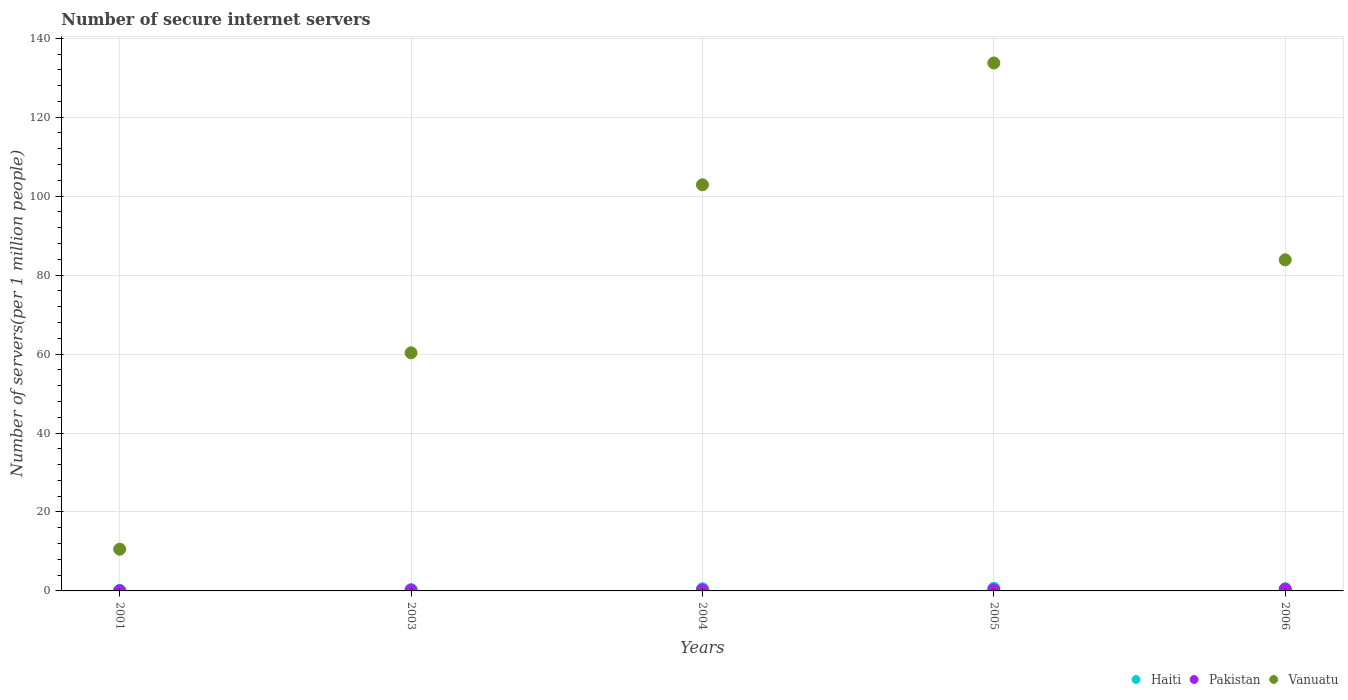Is the number of dotlines equal to the number of legend labels?
Make the answer very short. Yes. What is the number of secure internet servers in Haiti in 2005?
Your answer should be compact. 0.65. Across all years, what is the maximum number of secure internet servers in Vanuatu?
Your answer should be compact. 133.73. Across all years, what is the minimum number of secure internet servers in Vanuatu?
Ensure brevity in your answer.  10.57. In which year was the number of secure internet servers in Haiti maximum?
Provide a short and direct response. 2005. What is the total number of secure internet servers in Pakistan in the graph?
Your answer should be compact. 1.2. What is the difference between the number of secure internet servers in Vanuatu in 2001 and that in 2003?
Offer a very short reply. -49.75. What is the difference between the number of secure internet servers in Haiti in 2004 and the number of secure internet servers in Pakistan in 2001?
Offer a terse response. 0.51. What is the average number of secure internet servers in Vanuatu per year?
Your response must be concise. 78.27. In the year 2001, what is the difference between the number of secure internet servers in Pakistan and number of secure internet servers in Haiti?
Make the answer very short. -0.07. In how many years, is the number of secure internet servers in Pakistan greater than 136?
Provide a short and direct response. 0. What is the ratio of the number of secure internet servers in Haiti in 2004 to that in 2005?
Keep it short and to the point. 0.85. Is the number of secure internet servers in Haiti in 2001 less than that in 2004?
Your answer should be compact. Yes. What is the difference between the highest and the second highest number of secure internet servers in Pakistan?
Your response must be concise. 0.14. What is the difference between the highest and the lowest number of secure internet servers in Pakistan?
Give a very brief answer. 0.4. In how many years, is the number of secure internet servers in Haiti greater than the average number of secure internet servers in Haiti taken over all years?
Make the answer very short. 3. Is the number of secure internet servers in Pakistan strictly greater than the number of secure internet servers in Vanuatu over the years?
Your response must be concise. No. How many years are there in the graph?
Provide a short and direct response. 5. What is the difference between two consecutive major ticks on the Y-axis?
Give a very brief answer. 20. Are the values on the major ticks of Y-axis written in scientific E-notation?
Keep it short and to the point. No. Where does the legend appear in the graph?
Your answer should be very brief. Bottom right. How many legend labels are there?
Your response must be concise. 3. How are the legend labels stacked?
Keep it short and to the point. Horizontal. What is the title of the graph?
Make the answer very short. Number of secure internet servers. Does "Brazil" appear as one of the legend labels in the graph?
Make the answer very short. No. What is the label or title of the X-axis?
Your answer should be very brief. Years. What is the label or title of the Y-axis?
Give a very brief answer. Number of servers(per 1 million people). What is the Number of servers(per 1 million people) of Haiti in 2001?
Give a very brief answer. 0.12. What is the Number of servers(per 1 million people) of Pakistan in 2001?
Your answer should be very brief. 0.04. What is the Number of servers(per 1 million people) of Vanuatu in 2001?
Provide a short and direct response. 10.57. What is the Number of servers(per 1 million people) in Haiti in 2003?
Offer a very short reply. 0.33. What is the Number of servers(per 1 million people) of Pakistan in 2003?
Give a very brief answer. 0.17. What is the Number of servers(per 1 million people) in Vanuatu in 2003?
Provide a short and direct response. 60.31. What is the Number of servers(per 1 million people) in Haiti in 2004?
Give a very brief answer. 0.55. What is the Number of servers(per 1 million people) of Pakistan in 2004?
Provide a succinct answer. 0.25. What is the Number of servers(per 1 million people) of Vanuatu in 2004?
Your answer should be compact. 102.87. What is the Number of servers(per 1 million people) of Haiti in 2005?
Make the answer very short. 0.65. What is the Number of servers(per 1 million people) in Pakistan in 2005?
Offer a very short reply. 0.3. What is the Number of servers(per 1 million people) of Vanuatu in 2005?
Make the answer very short. 133.73. What is the Number of servers(per 1 million people) of Haiti in 2006?
Offer a very short reply. 0.53. What is the Number of servers(per 1 million people) in Pakistan in 2006?
Keep it short and to the point. 0.44. What is the Number of servers(per 1 million people) of Vanuatu in 2006?
Your answer should be compact. 83.86. Across all years, what is the maximum Number of servers(per 1 million people) in Haiti?
Your answer should be very brief. 0.65. Across all years, what is the maximum Number of servers(per 1 million people) of Pakistan?
Your answer should be very brief. 0.44. Across all years, what is the maximum Number of servers(per 1 million people) in Vanuatu?
Your response must be concise. 133.73. Across all years, what is the minimum Number of servers(per 1 million people) of Haiti?
Your answer should be very brief. 0.12. Across all years, what is the minimum Number of servers(per 1 million people) in Pakistan?
Offer a terse response. 0.04. Across all years, what is the minimum Number of servers(per 1 million people) of Vanuatu?
Keep it short and to the point. 10.57. What is the total Number of servers(per 1 million people) in Haiti in the graph?
Offer a very short reply. 2.18. What is the total Number of servers(per 1 million people) of Pakistan in the graph?
Your response must be concise. 1.2. What is the total Number of servers(per 1 million people) in Vanuatu in the graph?
Your response must be concise. 391.34. What is the difference between the Number of servers(per 1 million people) of Haiti in 2001 and that in 2003?
Keep it short and to the point. -0.22. What is the difference between the Number of servers(per 1 million people) of Pakistan in 2001 and that in 2003?
Your answer should be very brief. -0.13. What is the difference between the Number of servers(per 1 million people) of Vanuatu in 2001 and that in 2003?
Provide a succinct answer. -49.75. What is the difference between the Number of servers(per 1 million people) of Haiti in 2001 and that in 2004?
Keep it short and to the point. -0.43. What is the difference between the Number of servers(per 1 million people) of Pakistan in 2001 and that in 2004?
Ensure brevity in your answer.  -0.2. What is the difference between the Number of servers(per 1 million people) of Vanuatu in 2001 and that in 2004?
Make the answer very short. -92.3. What is the difference between the Number of servers(per 1 million people) in Haiti in 2001 and that in 2005?
Offer a terse response. -0.53. What is the difference between the Number of servers(per 1 million people) of Pakistan in 2001 and that in 2005?
Provide a succinct answer. -0.26. What is the difference between the Number of servers(per 1 million people) in Vanuatu in 2001 and that in 2005?
Offer a very short reply. -123.17. What is the difference between the Number of servers(per 1 million people) of Haiti in 2001 and that in 2006?
Keep it short and to the point. -0.42. What is the difference between the Number of servers(per 1 million people) of Pakistan in 2001 and that in 2006?
Provide a succinct answer. -0.4. What is the difference between the Number of servers(per 1 million people) in Vanuatu in 2001 and that in 2006?
Provide a short and direct response. -73.3. What is the difference between the Number of servers(per 1 million people) of Haiti in 2003 and that in 2004?
Offer a very short reply. -0.21. What is the difference between the Number of servers(per 1 million people) of Pakistan in 2003 and that in 2004?
Provide a short and direct response. -0.08. What is the difference between the Number of servers(per 1 million people) in Vanuatu in 2003 and that in 2004?
Give a very brief answer. -42.56. What is the difference between the Number of servers(per 1 million people) of Haiti in 2003 and that in 2005?
Provide a short and direct response. -0.31. What is the difference between the Number of servers(per 1 million people) of Pakistan in 2003 and that in 2005?
Provide a succinct answer. -0.13. What is the difference between the Number of servers(per 1 million people) of Vanuatu in 2003 and that in 2005?
Offer a terse response. -73.42. What is the difference between the Number of servers(per 1 million people) in Haiti in 2003 and that in 2006?
Give a very brief answer. -0.2. What is the difference between the Number of servers(per 1 million people) of Pakistan in 2003 and that in 2006?
Make the answer very short. -0.27. What is the difference between the Number of servers(per 1 million people) of Vanuatu in 2003 and that in 2006?
Offer a terse response. -23.55. What is the difference between the Number of servers(per 1 million people) in Haiti in 2004 and that in 2005?
Make the answer very short. -0.1. What is the difference between the Number of servers(per 1 million people) of Pakistan in 2004 and that in 2005?
Make the answer very short. -0.05. What is the difference between the Number of servers(per 1 million people) of Vanuatu in 2004 and that in 2005?
Give a very brief answer. -30.86. What is the difference between the Number of servers(per 1 million people) of Haiti in 2004 and that in 2006?
Ensure brevity in your answer.  0.02. What is the difference between the Number of servers(per 1 million people) of Pakistan in 2004 and that in 2006?
Keep it short and to the point. -0.19. What is the difference between the Number of servers(per 1 million people) of Vanuatu in 2004 and that in 2006?
Your answer should be compact. 19.01. What is the difference between the Number of servers(per 1 million people) of Haiti in 2005 and that in 2006?
Make the answer very short. 0.12. What is the difference between the Number of servers(per 1 million people) in Pakistan in 2005 and that in 2006?
Your answer should be compact. -0.14. What is the difference between the Number of servers(per 1 million people) of Vanuatu in 2005 and that in 2006?
Ensure brevity in your answer.  49.87. What is the difference between the Number of servers(per 1 million people) in Haiti in 2001 and the Number of servers(per 1 million people) in Pakistan in 2003?
Your answer should be very brief. -0.05. What is the difference between the Number of servers(per 1 million people) in Haiti in 2001 and the Number of servers(per 1 million people) in Vanuatu in 2003?
Your answer should be compact. -60.2. What is the difference between the Number of servers(per 1 million people) of Pakistan in 2001 and the Number of servers(per 1 million people) of Vanuatu in 2003?
Provide a short and direct response. -60.27. What is the difference between the Number of servers(per 1 million people) of Haiti in 2001 and the Number of servers(per 1 million people) of Pakistan in 2004?
Your answer should be compact. -0.13. What is the difference between the Number of servers(per 1 million people) in Haiti in 2001 and the Number of servers(per 1 million people) in Vanuatu in 2004?
Give a very brief answer. -102.75. What is the difference between the Number of servers(per 1 million people) of Pakistan in 2001 and the Number of servers(per 1 million people) of Vanuatu in 2004?
Keep it short and to the point. -102.83. What is the difference between the Number of servers(per 1 million people) in Haiti in 2001 and the Number of servers(per 1 million people) in Pakistan in 2005?
Your answer should be very brief. -0.18. What is the difference between the Number of servers(per 1 million people) of Haiti in 2001 and the Number of servers(per 1 million people) of Vanuatu in 2005?
Offer a terse response. -133.62. What is the difference between the Number of servers(per 1 million people) in Pakistan in 2001 and the Number of servers(per 1 million people) in Vanuatu in 2005?
Give a very brief answer. -133.69. What is the difference between the Number of servers(per 1 million people) in Haiti in 2001 and the Number of servers(per 1 million people) in Pakistan in 2006?
Offer a terse response. -0.33. What is the difference between the Number of servers(per 1 million people) of Haiti in 2001 and the Number of servers(per 1 million people) of Vanuatu in 2006?
Give a very brief answer. -83.75. What is the difference between the Number of servers(per 1 million people) of Pakistan in 2001 and the Number of servers(per 1 million people) of Vanuatu in 2006?
Provide a succinct answer. -83.82. What is the difference between the Number of servers(per 1 million people) of Haiti in 2003 and the Number of servers(per 1 million people) of Pakistan in 2004?
Make the answer very short. 0.09. What is the difference between the Number of servers(per 1 million people) of Haiti in 2003 and the Number of servers(per 1 million people) of Vanuatu in 2004?
Keep it short and to the point. -102.53. What is the difference between the Number of servers(per 1 million people) in Pakistan in 2003 and the Number of servers(per 1 million people) in Vanuatu in 2004?
Ensure brevity in your answer.  -102.7. What is the difference between the Number of servers(per 1 million people) of Haiti in 2003 and the Number of servers(per 1 million people) of Pakistan in 2005?
Your answer should be very brief. 0.03. What is the difference between the Number of servers(per 1 million people) of Haiti in 2003 and the Number of servers(per 1 million people) of Vanuatu in 2005?
Give a very brief answer. -133.4. What is the difference between the Number of servers(per 1 million people) in Pakistan in 2003 and the Number of servers(per 1 million people) in Vanuatu in 2005?
Make the answer very short. -133.56. What is the difference between the Number of servers(per 1 million people) of Haiti in 2003 and the Number of servers(per 1 million people) of Pakistan in 2006?
Your answer should be very brief. -0.11. What is the difference between the Number of servers(per 1 million people) of Haiti in 2003 and the Number of servers(per 1 million people) of Vanuatu in 2006?
Your response must be concise. -83.53. What is the difference between the Number of servers(per 1 million people) of Pakistan in 2003 and the Number of servers(per 1 million people) of Vanuatu in 2006?
Ensure brevity in your answer.  -83.69. What is the difference between the Number of servers(per 1 million people) in Haiti in 2004 and the Number of servers(per 1 million people) in Pakistan in 2005?
Give a very brief answer. 0.25. What is the difference between the Number of servers(per 1 million people) in Haiti in 2004 and the Number of servers(per 1 million people) in Vanuatu in 2005?
Your answer should be compact. -133.18. What is the difference between the Number of servers(per 1 million people) in Pakistan in 2004 and the Number of servers(per 1 million people) in Vanuatu in 2005?
Offer a very short reply. -133.49. What is the difference between the Number of servers(per 1 million people) in Haiti in 2004 and the Number of servers(per 1 million people) in Pakistan in 2006?
Your response must be concise. 0.11. What is the difference between the Number of servers(per 1 million people) in Haiti in 2004 and the Number of servers(per 1 million people) in Vanuatu in 2006?
Make the answer very short. -83.31. What is the difference between the Number of servers(per 1 million people) of Pakistan in 2004 and the Number of servers(per 1 million people) of Vanuatu in 2006?
Provide a succinct answer. -83.62. What is the difference between the Number of servers(per 1 million people) of Haiti in 2005 and the Number of servers(per 1 million people) of Pakistan in 2006?
Provide a short and direct response. 0.21. What is the difference between the Number of servers(per 1 million people) of Haiti in 2005 and the Number of servers(per 1 million people) of Vanuatu in 2006?
Your response must be concise. -83.22. What is the difference between the Number of servers(per 1 million people) of Pakistan in 2005 and the Number of servers(per 1 million people) of Vanuatu in 2006?
Your answer should be compact. -83.56. What is the average Number of servers(per 1 million people) in Haiti per year?
Offer a terse response. 0.44. What is the average Number of servers(per 1 million people) of Pakistan per year?
Make the answer very short. 0.24. What is the average Number of servers(per 1 million people) of Vanuatu per year?
Your answer should be very brief. 78.27. In the year 2001, what is the difference between the Number of servers(per 1 million people) in Haiti and Number of servers(per 1 million people) in Pakistan?
Offer a terse response. 0.07. In the year 2001, what is the difference between the Number of servers(per 1 million people) in Haiti and Number of servers(per 1 million people) in Vanuatu?
Offer a terse response. -10.45. In the year 2001, what is the difference between the Number of servers(per 1 million people) of Pakistan and Number of servers(per 1 million people) of Vanuatu?
Offer a terse response. -10.52. In the year 2003, what is the difference between the Number of servers(per 1 million people) in Haiti and Number of servers(per 1 million people) in Pakistan?
Ensure brevity in your answer.  0.16. In the year 2003, what is the difference between the Number of servers(per 1 million people) of Haiti and Number of servers(per 1 million people) of Vanuatu?
Give a very brief answer. -59.98. In the year 2003, what is the difference between the Number of servers(per 1 million people) in Pakistan and Number of servers(per 1 million people) in Vanuatu?
Offer a terse response. -60.14. In the year 2004, what is the difference between the Number of servers(per 1 million people) of Haiti and Number of servers(per 1 million people) of Pakistan?
Ensure brevity in your answer.  0.3. In the year 2004, what is the difference between the Number of servers(per 1 million people) in Haiti and Number of servers(per 1 million people) in Vanuatu?
Provide a succinct answer. -102.32. In the year 2004, what is the difference between the Number of servers(per 1 million people) in Pakistan and Number of servers(per 1 million people) in Vanuatu?
Your answer should be very brief. -102.62. In the year 2005, what is the difference between the Number of servers(per 1 million people) of Haiti and Number of servers(per 1 million people) of Pakistan?
Provide a succinct answer. 0.35. In the year 2005, what is the difference between the Number of servers(per 1 million people) of Haiti and Number of servers(per 1 million people) of Vanuatu?
Offer a very short reply. -133.08. In the year 2005, what is the difference between the Number of servers(per 1 million people) of Pakistan and Number of servers(per 1 million people) of Vanuatu?
Give a very brief answer. -133.43. In the year 2006, what is the difference between the Number of servers(per 1 million people) in Haiti and Number of servers(per 1 million people) in Pakistan?
Your answer should be compact. 0.09. In the year 2006, what is the difference between the Number of servers(per 1 million people) of Haiti and Number of servers(per 1 million people) of Vanuatu?
Your answer should be very brief. -83.33. In the year 2006, what is the difference between the Number of servers(per 1 million people) in Pakistan and Number of servers(per 1 million people) in Vanuatu?
Your answer should be compact. -83.42. What is the ratio of the Number of servers(per 1 million people) of Haiti in 2001 to that in 2003?
Keep it short and to the point. 0.34. What is the ratio of the Number of servers(per 1 million people) in Pakistan in 2001 to that in 2003?
Make the answer very short. 0.25. What is the ratio of the Number of servers(per 1 million people) in Vanuatu in 2001 to that in 2003?
Offer a terse response. 0.18. What is the ratio of the Number of servers(per 1 million people) in Haiti in 2001 to that in 2004?
Your answer should be compact. 0.21. What is the ratio of the Number of servers(per 1 million people) of Pakistan in 2001 to that in 2004?
Provide a short and direct response. 0.17. What is the ratio of the Number of servers(per 1 million people) in Vanuatu in 2001 to that in 2004?
Your response must be concise. 0.1. What is the ratio of the Number of servers(per 1 million people) in Haiti in 2001 to that in 2005?
Offer a very short reply. 0.18. What is the ratio of the Number of servers(per 1 million people) of Pakistan in 2001 to that in 2005?
Provide a short and direct response. 0.14. What is the ratio of the Number of servers(per 1 million people) in Vanuatu in 2001 to that in 2005?
Keep it short and to the point. 0.08. What is the ratio of the Number of servers(per 1 million people) in Haiti in 2001 to that in 2006?
Keep it short and to the point. 0.22. What is the ratio of the Number of servers(per 1 million people) of Pakistan in 2001 to that in 2006?
Offer a very short reply. 0.1. What is the ratio of the Number of servers(per 1 million people) of Vanuatu in 2001 to that in 2006?
Your answer should be very brief. 0.13. What is the ratio of the Number of servers(per 1 million people) in Haiti in 2003 to that in 2004?
Your answer should be very brief. 0.61. What is the ratio of the Number of servers(per 1 million people) in Pakistan in 2003 to that in 2004?
Give a very brief answer. 0.69. What is the ratio of the Number of servers(per 1 million people) in Vanuatu in 2003 to that in 2004?
Provide a succinct answer. 0.59. What is the ratio of the Number of servers(per 1 million people) in Haiti in 2003 to that in 2005?
Your response must be concise. 0.52. What is the ratio of the Number of servers(per 1 million people) in Pakistan in 2003 to that in 2005?
Your answer should be compact. 0.57. What is the ratio of the Number of servers(per 1 million people) in Vanuatu in 2003 to that in 2005?
Your response must be concise. 0.45. What is the ratio of the Number of servers(per 1 million people) of Haiti in 2003 to that in 2006?
Ensure brevity in your answer.  0.63. What is the ratio of the Number of servers(per 1 million people) of Pakistan in 2003 to that in 2006?
Your answer should be compact. 0.39. What is the ratio of the Number of servers(per 1 million people) of Vanuatu in 2003 to that in 2006?
Give a very brief answer. 0.72. What is the ratio of the Number of servers(per 1 million people) in Haiti in 2004 to that in 2005?
Ensure brevity in your answer.  0.85. What is the ratio of the Number of servers(per 1 million people) in Pakistan in 2004 to that in 2005?
Make the answer very short. 0.82. What is the ratio of the Number of servers(per 1 million people) in Vanuatu in 2004 to that in 2005?
Keep it short and to the point. 0.77. What is the ratio of the Number of servers(per 1 million people) of Haiti in 2004 to that in 2006?
Make the answer very short. 1.03. What is the ratio of the Number of servers(per 1 million people) of Pakistan in 2004 to that in 2006?
Give a very brief answer. 0.56. What is the ratio of the Number of servers(per 1 million people) of Vanuatu in 2004 to that in 2006?
Make the answer very short. 1.23. What is the ratio of the Number of servers(per 1 million people) of Haiti in 2005 to that in 2006?
Offer a terse response. 1.22. What is the ratio of the Number of servers(per 1 million people) in Pakistan in 2005 to that in 2006?
Your answer should be very brief. 0.68. What is the ratio of the Number of servers(per 1 million people) of Vanuatu in 2005 to that in 2006?
Offer a very short reply. 1.59. What is the difference between the highest and the second highest Number of servers(per 1 million people) of Haiti?
Give a very brief answer. 0.1. What is the difference between the highest and the second highest Number of servers(per 1 million people) in Pakistan?
Keep it short and to the point. 0.14. What is the difference between the highest and the second highest Number of servers(per 1 million people) of Vanuatu?
Your answer should be compact. 30.86. What is the difference between the highest and the lowest Number of servers(per 1 million people) in Haiti?
Give a very brief answer. 0.53. What is the difference between the highest and the lowest Number of servers(per 1 million people) of Pakistan?
Give a very brief answer. 0.4. What is the difference between the highest and the lowest Number of servers(per 1 million people) in Vanuatu?
Your response must be concise. 123.17. 